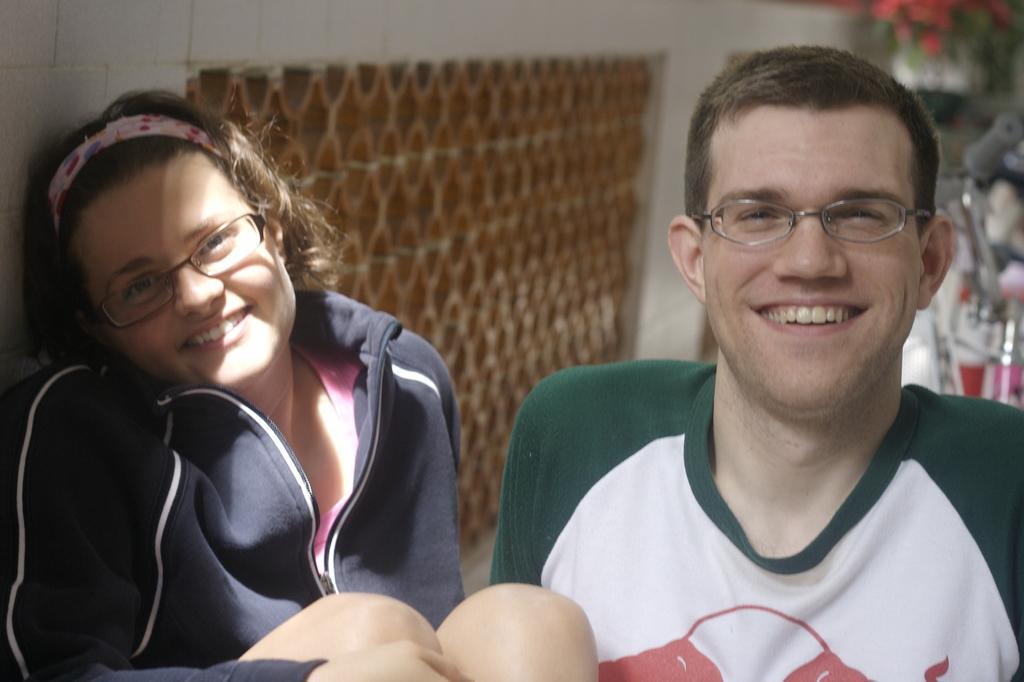In one or two sentences, can you explain what this image depicts? In this image we can see a man and a woman. They are smiling. The man is wearing a T-shirt and the woman is wearing pink top and jacket. In the background, we can see the wall and mesh. We can see a bicycle and a flower pot on the right side of the image. 